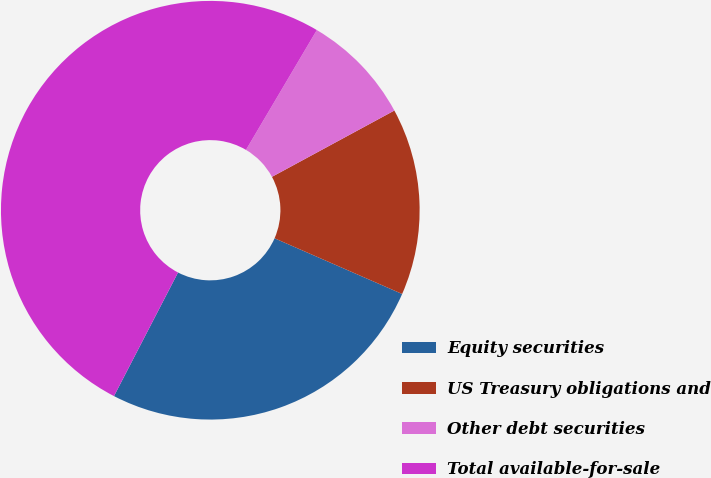Convert chart to OTSL. <chart><loc_0><loc_0><loc_500><loc_500><pie_chart><fcel>Equity securities<fcel>US Treasury obligations and<fcel>Other debt securities<fcel>Total available-for-sale<nl><fcel>26.06%<fcel>14.45%<fcel>8.6%<fcel>50.89%<nl></chart> 